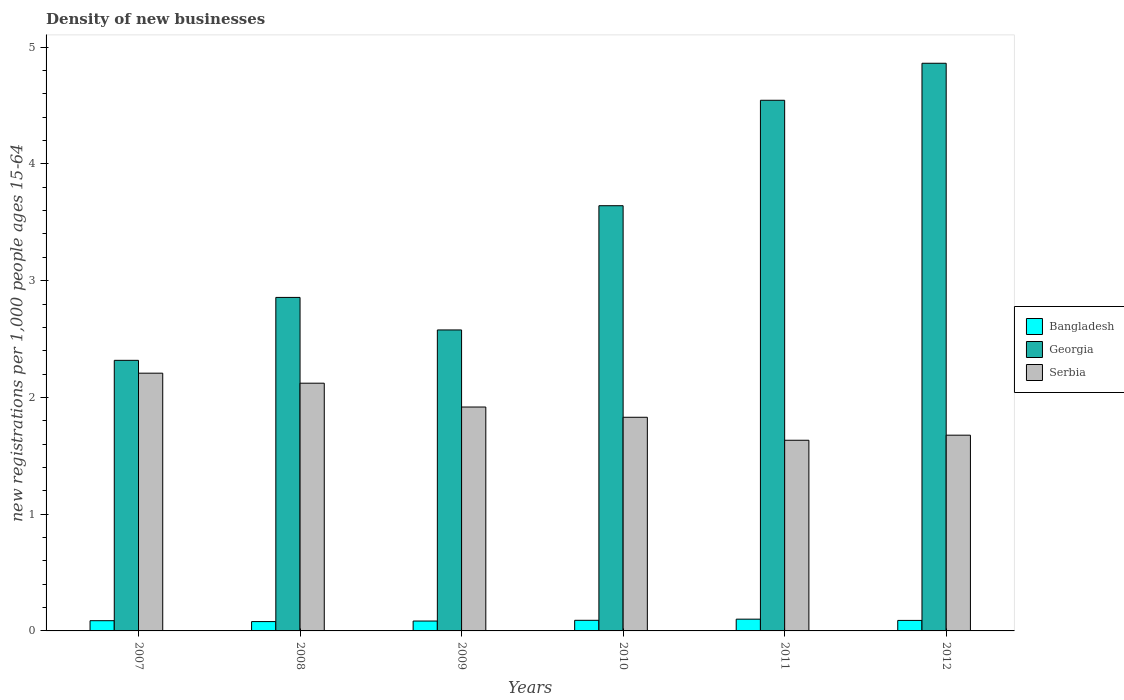How many different coloured bars are there?
Offer a terse response. 3. How many groups of bars are there?
Provide a short and direct response. 6. How many bars are there on the 3rd tick from the left?
Ensure brevity in your answer.  3. How many bars are there on the 5th tick from the right?
Provide a succinct answer. 3. In how many cases, is the number of bars for a given year not equal to the number of legend labels?
Your response must be concise. 0. What is the number of new registrations in Bangladesh in 2007?
Your answer should be compact. 0.09. Across all years, what is the maximum number of new registrations in Georgia?
Provide a short and direct response. 4.86. Across all years, what is the minimum number of new registrations in Georgia?
Offer a very short reply. 2.32. In which year was the number of new registrations in Serbia maximum?
Give a very brief answer. 2007. In which year was the number of new registrations in Bangladesh minimum?
Provide a short and direct response. 2008. What is the total number of new registrations in Serbia in the graph?
Offer a terse response. 11.39. What is the difference between the number of new registrations in Serbia in 2007 and that in 2009?
Ensure brevity in your answer.  0.29. What is the difference between the number of new registrations in Georgia in 2010 and the number of new registrations in Serbia in 2012?
Offer a terse response. 1.97. What is the average number of new registrations in Georgia per year?
Your answer should be very brief. 3.47. In the year 2007, what is the difference between the number of new registrations in Bangladesh and number of new registrations in Georgia?
Offer a very short reply. -2.23. What is the ratio of the number of new registrations in Bangladesh in 2009 to that in 2012?
Your answer should be compact. 0.94. Is the number of new registrations in Serbia in 2010 less than that in 2012?
Make the answer very short. No. What is the difference between the highest and the second highest number of new registrations in Serbia?
Make the answer very short. 0.09. What is the difference between the highest and the lowest number of new registrations in Georgia?
Give a very brief answer. 2.54. What does the 2nd bar from the left in 2008 represents?
Keep it short and to the point. Georgia. Is it the case that in every year, the sum of the number of new registrations in Bangladesh and number of new registrations in Georgia is greater than the number of new registrations in Serbia?
Offer a very short reply. Yes. Are the values on the major ticks of Y-axis written in scientific E-notation?
Keep it short and to the point. No. Does the graph contain grids?
Provide a succinct answer. No. How are the legend labels stacked?
Your answer should be compact. Vertical. What is the title of the graph?
Your answer should be compact. Density of new businesses. Does "High income" appear as one of the legend labels in the graph?
Give a very brief answer. No. What is the label or title of the X-axis?
Your answer should be compact. Years. What is the label or title of the Y-axis?
Your answer should be very brief. New registrations per 1,0 people ages 15-64. What is the new registrations per 1,000 people ages 15-64 of Bangladesh in 2007?
Offer a very short reply. 0.09. What is the new registrations per 1,000 people ages 15-64 in Georgia in 2007?
Provide a short and direct response. 2.32. What is the new registrations per 1,000 people ages 15-64 in Serbia in 2007?
Make the answer very short. 2.21. What is the new registrations per 1,000 people ages 15-64 of Bangladesh in 2008?
Provide a short and direct response. 0.08. What is the new registrations per 1,000 people ages 15-64 of Georgia in 2008?
Keep it short and to the point. 2.86. What is the new registrations per 1,000 people ages 15-64 in Serbia in 2008?
Offer a very short reply. 2.12. What is the new registrations per 1,000 people ages 15-64 of Bangladesh in 2009?
Offer a very short reply. 0.08. What is the new registrations per 1,000 people ages 15-64 of Georgia in 2009?
Your answer should be very brief. 2.58. What is the new registrations per 1,000 people ages 15-64 in Serbia in 2009?
Make the answer very short. 1.92. What is the new registrations per 1,000 people ages 15-64 in Bangladesh in 2010?
Your answer should be compact. 0.09. What is the new registrations per 1,000 people ages 15-64 in Georgia in 2010?
Give a very brief answer. 3.64. What is the new registrations per 1,000 people ages 15-64 in Serbia in 2010?
Keep it short and to the point. 1.83. What is the new registrations per 1,000 people ages 15-64 of Bangladesh in 2011?
Ensure brevity in your answer.  0.1. What is the new registrations per 1,000 people ages 15-64 in Georgia in 2011?
Your response must be concise. 4.55. What is the new registrations per 1,000 people ages 15-64 of Serbia in 2011?
Ensure brevity in your answer.  1.63. What is the new registrations per 1,000 people ages 15-64 of Bangladesh in 2012?
Your response must be concise. 0.09. What is the new registrations per 1,000 people ages 15-64 in Georgia in 2012?
Your answer should be very brief. 4.86. What is the new registrations per 1,000 people ages 15-64 in Serbia in 2012?
Offer a very short reply. 1.68. Across all years, what is the maximum new registrations per 1,000 people ages 15-64 in Bangladesh?
Offer a very short reply. 0.1. Across all years, what is the maximum new registrations per 1,000 people ages 15-64 of Georgia?
Make the answer very short. 4.86. Across all years, what is the maximum new registrations per 1,000 people ages 15-64 in Serbia?
Provide a short and direct response. 2.21. Across all years, what is the minimum new registrations per 1,000 people ages 15-64 of Bangladesh?
Make the answer very short. 0.08. Across all years, what is the minimum new registrations per 1,000 people ages 15-64 of Georgia?
Give a very brief answer. 2.32. Across all years, what is the minimum new registrations per 1,000 people ages 15-64 in Serbia?
Your answer should be very brief. 1.63. What is the total new registrations per 1,000 people ages 15-64 of Bangladesh in the graph?
Your answer should be very brief. 0.53. What is the total new registrations per 1,000 people ages 15-64 of Georgia in the graph?
Your answer should be very brief. 20.8. What is the total new registrations per 1,000 people ages 15-64 of Serbia in the graph?
Make the answer very short. 11.39. What is the difference between the new registrations per 1,000 people ages 15-64 of Bangladesh in 2007 and that in 2008?
Keep it short and to the point. 0.01. What is the difference between the new registrations per 1,000 people ages 15-64 in Georgia in 2007 and that in 2008?
Give a very brief answer. -0.54. What is the difference between the new registrations per 1,000 people ages 15-64 in Serbia in 2007 and that in 2008?
Your answer should be compact. 0.09. What is the difference between the new registrations per 1,000 people ages 15-64 in Bangladesh in 2007 and that in 2009?
Give a very brief answer. 0. What is the difference between the new registrations per 1,000 people ages 15-64 in Georgia in 2007 and that in 2009?
Provide a succinct answer. -0.26. What is the difference between the new registrations per 1,000 people ages 15-64 in Serbia in 2007 and that in 2009?
Your response must be concise. 0.29. What is the difference between the new registrations per 1,000 people ages 15-64 in Bangladesh in 2007 and that in 2010?
Your answer should be very brief. -0. What is the difference between the new registrations per 1,000 people ages 15-64 of Georgia in 2007 and that in 2010?
Your answer should be compact. -1.32. What is the difference between the new registrations per 1,000 people ages 15-64 of Serbia in 2007 and that in 2010?
Your answer should be compact. 0.38. What is the difference between the new registrations per 1,000 people ages 15-64 in Bangladesh in 2007 and that in 2011?
Your response must be concise. -0.01. What is the difference between the new registrations per 1,000 people ages 15-64 of Georgia in 2007 and that in 2011?
Your answer should be very brief. -2.23. What is the difference between the new registrations per 1,000 people ages 15-64 of Serbia in 2007 and that in 2011?
Offer a very short reply. 0.57. What is the difference between the new registrations per 1,000 people ages 15-64 in Bangladesh in 2007 and that in 2012?
Offer a terse response. -0. What is the difference between the new registrations per 1,000 people ages 15-64 of Georgia in 2007 and that in 2012?
Your response must be concise. -2.54. What is the difference between the new registrations per 1,000 people ages 15-64 in Serbia in 2007 and that in 2012?
Your response must be concise. 0.53. What is the difference between the new registrations per 1,000 people ages 15-64 of Bangladesh in 2008 and that in 2009?
Your answer should be compact. -0. What is the difference between the new registrations per 1,000 people ages 15-64 in Georgia in 2008 and that in 2009?
Your answer should be very brief. 0.28. What is the difference between the new registrations per 1,000 people ages 15-64 of Serbia in 2008 and that in 2009?
Make the answer very short. 0.2. What is the difference between the new registrations per 1,000 people ages 15-64 in Bangladesh in 2008 and that in 2010?
Offer a terse response. -0.01. What is the difference between the new registrations per 1,000 people ages 15-64 in Georgia in 2008 and that in 2010?
Your answer should be compact. -0.79. What is the difference between the new registrations per 1,000 people ages 15-64 in Serbia in 2008 and that in 2010?
Make the answer very short. 0.29. What is the difference between the new registrations per 1,000 people ages 15-64 of Bangladesh in 2008 and that in 2011?
Offer a terse response. -0.02. What is the difference between the new registrations per 1,000 people ages 15-64 in Georgia in 2008 and that in 2011?
Your answer should be compact. -1.69. What is the difference between the new registrations per 1,000 people ages 15-64 of Serbia in 2008 and that in 2011?
Make the answer very short. 0.49. What is the difference between the new registrations per 1,000 people ages 15-64 in Bangladesh in 2008 and that in 2012?
Make the answer very short. -0.01. What is the difference between the new registrations per 1,000 people ages 15-64 in Georgia in 2008 and that in 2012?
Your answer should be compact. -2.01. What is the difference between the new registrations per 1,000 people ages 15-64 in Serbia in 2008 and that in 2012?
Ensure brevity in your answer.  0.45. What is the difference between the new registrations per 1,000 people ages 15-64 of Bangladesh in 2009 and that in 2010?
Ensure brevity in your answer.  -0.01. What is the difference between the new registrations per 1,000 people ages 15-64 of Georgia in 2009 and that in 2010?
Offer a very short reply. -1.06. What is the difference between the new registrations per 1,000 people ages 15-64 of Serbia in 2009 and that in 2010?
Your response must be concise. 0.09. What is the difference between the new registrations per 1,000 people ages 15-64 in Bangladesh in 2009 and that in 2011?
Your answer should be compact. -0.02. What is the difference between the new registrations per 1,000 people ages 15-64 of Georgia in 2009 and that in 2011?
Give a very brief answer. -1.97. What is the difference between the new registrations per 1,000 people ages 15-64 of Serbia in 2009 and that in 2011?
Offer a very short reply. 0.28. What is the difference between the new registrations per 1,000 people ages 15-64 in Bangladesh in 2009 and that in 2012?
Keep it short and to the point. -0.01. What is the difference between the new registrations per 1,000 people ages 15-64 of Georgia in 2009 and that in 2012?
Your response must be concise. -2.28. What is the difference between the new registrations per 1,000 people ages 15-64 in Serbia in 2009 and that in 2012?
Keep it short and to the point. 0.24. What is the difference between the new registrations per 1,000 people ages 15-64 in Bangladesh in 2010 and that in 2011?
Your response must be concise. -0.01. What is the difference between the new registrations per 1,000 people ages 15-64 in Georgia in 2010 and that in 2011?
Your answer should be very brief. -0.9. What is the difference between the new registrations per 1,000 people ages 15-64 of Serbia in 2010 and that in 2011?
Your answer should be compact. 0.2. What is the difference between the new registrations per 1,000 people ages 15-64 in Bangladesh in 2010 and that in 2012?
Offer a terse response. 0. What is the difference between the new registrations per 1,000 people ages 15-64 in Georgia in 2010 and that in 2012?
Your answer should be compact. -1.22. What is the difference between the new registrations per 1,000 people ages 15-64 in Serbia in 2010 and that in 2012?
Ensure brevity in your answer.  0.15. What is the difference between the new registrations per 1,000 people ages 15-64 in Bangladesh in 2011 and that in 2012?
Your answer should be compact. 0.01. What is the difference between the new registrations per 1,000 people ages 15-64 in Georgia in 2011 and that in 2012?
Provide a short and direct response. -0.32. What is the difference between the new registrations per 1,000 people ages 15-64 of Serbia in 2011 and that in 2012?
Provide a short and direct response. -0.04. What is the difference between the new registrations per 1,000 people ages 15-64 of Bangladesh in 2007 and the new registrations per 1,000 people ages 15-64 of Georgia in 2008?
Give a very brief answer. -2.77. What is the difference between the new registrations per 1,000 people ages 15-64 of Bangladesh in 2007 and the new registrations per 1,000 people ages 15-64 of Serbia in 2008?
Make the answer very short. -2.03. What is the difference between the new registrations per 1,000 people ages 15-64 of Georgia in 2007 and the new registrations per 1,000 people ages 15-64 of Serbia in 2008?
Ensure brevity in your answer.  0.2. What is the difference between the new registrations per 1,000 people ages 15-64 in Bangladesh in 2007 and the new registrations per 1,000 people ages 15-64 in Georgia in 2009?
Offer a very short reply. -2.49. What is the difference between the new registrations per 1,000 people ages 15-64 of Bangladesh in 2007 and the new registrations per 1,000 people ages 15-64 of Serbia in 2009?
Provide a short and direct response. -1.83. What is the difference between the new registrations per 1,000 people ages 15-64 of Bangladesh in 2007 and the new registrations per 1,000 people ages 15-64 of Georgia in 2010?
Offer a very short reply. -3.55. What is the difference between the new registrations per 1,000 people ages 15-64 in Bangladesh in 2007 and the new registrations per 1,000 people ages 15-64 in Serbia in 2010?
Your response must be concise. -1.74. What is the difference between the new registrations per 1,000 people ages 15-64 in Georgia in 2007 and the new registrations per 1,000 people ages 15-64 in Serbia in 2010?
Offer a terse response. 0.49. What is the difference between the new registrations per 1,000 people ages 15-64 in Bangladesh in 2007 and the new registrations per 1,000 people ages 15-64 in Georgia in 2011?
Give a very brief answer. -4.46. What is the difference between the new registrations per 1,000 people ages 15-64 in Bangladesh in 2007 and the new registrations per 1,000 people ages 15-64 in Serbia in 2011?
Make the answer very short. -1.55. What is the difference between the new registrations per 1,000 people ages 15-64 of Georgia in 2007 and the new registrations per 1,000 people ages 15-64 of Serbia in 2011?
Offer a terse response. 0.68. What is the difference between the new registrations per 1,000 people ages 15-64 in Bangladesh in 2007 and the new registrations per 1,000 people ages 15-64 in Georgia in 2012?
Ensure brevity in your answer.  -4.77. What is the difference between the new registrations per 1,000 people ages 15-64 of Bangladesh in 2007 and the new registrations per 1,000 people ages 15-64 of Serbia in 2012?
Ensure brevity in your answer.  -1.59. What is the difference between the new registrations per 1,000 people ages 15-64 of Georgia in 2007 and the new registrations per 1,000 people ages 15-64 of Serbia in 2012?
Offer a very short reply. 0.64. What is the difference between the new registrations per 1,000 people ages 15-64 in Bangladesh in 2008 and the new registrations per 1,000 people ages 15-64 in Georgia in 2009?
Offer a very short reply. -2.5. What is the difference between the new registrations per 1,000 people ages 15-64 in Bangladesh in 2008 and the new registrations per 1,000 people ages 15-64 in Serbia in 2009?
Your response must be concise. -1.84. What is the difference between the new registrations per 1,000 people ages 15-64 in Georgia in 2008 and the new registrations per 1,000 people ages 15-64 in Serbia in 2009?
Give a very brief answer. 0.94. What is the difference between the new registrations per 1,000 people ages 15-64 in Bangladesh in 2008 and the new registrations per 1,000 people ages 15-64 in Georgia in 2010?
Make the answer very short. -3.56. What is the difference between the new registrations per 1,000 people ages 15-64 in Bangladesh in 2008 and the new registrations per 1,000 people ages 15-64 in Serbia in 2010?
Ensure brevity in your answer.  -1.75. What is the difference between the new registrations per 1,000 people ages 15-64 in Georgia in 2008 and the new registrations per 1,000 people ages 15-64 in Serbia in 2010?
Give a very brief answer. 1.03. What is the difference between the new registrations per 1,000 people ages 15-64 in Bangladesh in 2008 and the new registrations per 1,000 people ages 15-64 in Georgia in 2011?
Your answer should be very brief. -4.47. What is the difference between the new registrations per 1,000 people ages 15-64 of Bangladesh in 2008 and the new registrations per 1,000 people ages 15-64 of Serbia in 2011?
Your answer should be very brief. -1.55. What is the difference between the new registrations per 1,000 people ages 15-64 in Georgia in 2008 and the new registrations per 1,000 people ages 15-64 in Serbia in 2011?
Provide a succinct answer. 1.22. What is the difference between the new registrations per 1,000 people ages 15-64 of Bangladesh in 2008 and the new registrations per 1,000 people ages 15-64 of Georgia in 2012?
Your answer should be compact. -4.78. What is the difference between the new registrations per 1,000 people ages 15-64 in Bangladesh in 2008 and the new registrations per 1,000 people ages 15-64 in Serbia in 2012?
Ensure brevity in your answer.  -1.6. What is the difference between the new registrations per 1,000 people ages 15-64 of Georgia in 2008 and the new registrations per 1,000 people ages 15-64 of Serbia in 2012?
Provide a short and direct response. 1.18. What is the difference between the new registrations per 1,000 people ages 15-64 in Bangladesh in 2009 and the new registrations per 1,000 people ages 15-64 in Georgia in 2010?
Your answer should be compact. -3.56. What is the difference between the new registrations per 1,000 people ages 15-64 in Bangladesh in 2009 and the new registrations per 1,000 people ages 15-64 in Serbia in 2010?
Make the answer very short. -1.75. What is the difference between the new registrations per 1,000 people ages 15-64 in Georgia in 2009 and the new registrations per 1,000 people ages 15-64 in Serbia in 2010?
Give a very brief answer. 0.75. What is the difference between the new registrations per 1,000 people ages 15-64 of Bangladesh in 2009 and the new registrations per 1,000 people ages 15-64 of Georgia in 2011?
Keep it short and to the point. -4.46. What is the difference between the new registrations per 1,000 people ages 15-64 in Bangladesh in 2009 and the new registrations per 1,000 people ages 15-64 in Serbia in 2011?
Provide a short and direct response. -1.55. What is the difference between the new registrations per 1,000 people ages 15-64 of Georgia in 2009 and the new registrations per 1,000 people ages 15-64 of Serbia in 2011?
Give a very brief answer. 0.94. What is the difference between the new registrations per 1,000 people ages 15-64 of Bangladesh in 2009 and the new registrations per 1,000 people ages 15-64 of Georgia in 2012?
Keep it short and to the point. -4.78. What is the difference between the new registrations per 1,000 people ages 15-64 of Bangladesh in 2009 and the new registrations per 1,000 people ages 15-64 of Serbia in 2012?
Your answer should be very brief. -1.59. What is the difference between the new registrations per 1,000 people ages 15-64 of Georgia in 2009 and the new registrations per 1,000 people ages 15-64 of Serbia in 2012?
Your answer should be very brief. 0.9. What is the difference between the new registrations per 1,000 people ages 15-64 of Bangladesh in 2010 and the new registrations per 1,000 people ages 15-64 of Georgia in 2011?
Your answer should be compact. -4.45. What is the difference between the new registrations per 1,000 people ages 15-64 in Bangladesh in 2010 and the new registrations per 1,000 people ages 15-64 in Serbia in 2011?
Your answer should be compact. -1.54. What is the difference between the new registrations per 1,000 people ages 15-64 of Georgia in 2010 and the new registrations per 1,000 people ages 15-64 of Serbia in 2011?
Offer a very short reply. 2.01. What is the difference between the new registrations per 1,000 people ages 15-64 in Bangladesh in 2010 and the new registrations per 1,000 people ages 15-64 in Georgia in 2012?
Keep it short and to the point. -4.77. What is the difference between the new registrations per 1,000 people ages 15-64 in Bangladesh in 2010 and the new registrations per 1,000 people ages 15-64 in Serbia in 2012?
Offer a terse response. -1.59. What is the difference between the new registrations per 1,000 people ages 15-64 in Georgia in 2010 and the new registrations per 1,000 people ages 15-64 in Serbia in 2012?
Make the answer very short. 1.97. What is the difference between the new registrations per 1,000 people ages 15-64 in Bangladesh in 2011 and the new registrations per 1,000 people ages 15-64 in Georgia in 2012?
Provide a short and direct response. -4.76. What is the difference between the new registrations per 1,000 people ages 15-64 in Bangladesh in 2011 and the new registrations per 1,000 people ages 15-64 in Serbia in 2012?
Keep it short and to the point. -1.58. What is the difference between the new registrations per 1,000 people ages 15-64 of Georgia in 2011 and the new registrations per 1,000 people ages 15-64 of Serbia in 2012?
Give a very brief answer. 2.87. What is the average new registrations per 1,000 people ages 15-64 of Bangladesh per year?
Make the answer very short. 0.09. What is the average new registrations per 1,000 people ages 15-64 in Georgia per year?
Your response must be concise. 3.47. What is the average new registrations per 1,000 people ages 15-64 of Serbia per year?
Provide a short and direct response. 1.9. In the year 2007, what is the difference between the new registrations per 1,000 people ages 15-64 of Bangladesh and new registrations per 1,000 people ages 15-64 of Georgia?
Offer a very short reply. -2.23. In the year 2007, what is the difference between the new registrations per 1,000 people ages 15-64 in Bangladesh and new registrations per 1,000 people ages 15-64 in Serbia?
Provide a short and direct response. -2.12. In the year 2007, what is the difference between the new registrations per 1,000 people ages 15-64 of Georgia and new registrations per 1,000 people ages 15-64 of Serbia?
Offer a very short reply. 0.11. In the year 2008, what is the difference between the new registrations per 1,000 people ages 15-64 in Bangladesh and new registrations per 1,000 people ages 15-64 in Georgia?
Provide a short and direct response. -2.78. In the year 2008, what is the difference between the new registrations per 1,000 people ages 15-64 of Bangladesh and new registrations per 1,000 people ages 15-64 of Serbia?
Keep it short and to the point. -2.04. In the year 2008, what is the difference between the new registrations per 1,000 people ages 15-64 of Georgia and new registrations per 1,000 people ages 15-64 of Serbia?
Keep it short and to the point. 0.73. In the year 2009, what is the difference between the new registrations per 1,000 people ages 15-64 in Bangladesh and new registrations per 1,000 people ages 15-64 in Georgia?
Make the answer very short. -2.49. In the year 2009, what is the difference between the new registrations per 1,000 people ages 15-64 of Bangladesh and new registrations per 1,000 people ages 15-64 of Serbia?
Keep it short and to the point. -1.83. In the year 2009, what is the difference between the new registrations per 1,000 people ages 15-64 in Georgia and new registrations per 1,000 people ages 15-64 in Serbia?
Ensure brevity in your answer.  0.66. In the year 2010, what is the difference between the new registrations per 1,000 people ages 15-64 in Bangladesh and new registrations per 1,000 people ages 15-64 in Georgia?
Offer a terse response. -3.55. In the year 2010, what is the difference between the new registrations per 1,000 people ages 15-64 of Bangladesh and new registrations per 1,000 people ages 15-64 of Serbia?
Your answer should be very brief. -1.74. In the year 2010, what is the difference between the new registrations per 1,000 people ages 15-64 in Georgia and new registrations per 1,000 people ages 15-64 in Serbia?
Your answer should be very brief. 1.81. In the year 2011, what is the difference between the new registrations per 1,000 people ages 15-64 in Bangladesh and new registrations per 1,000 people ages 15-64 in Georgia?
Offer a very short reply. -4.44. In the year 2011, what is the difference between the new registrations per 1,000 people ages 15-64 in Bangladesh and new registrations per 1,000 people ages 15-64 in Serbia?
Keep it short and to the point. -1.53. In the year 2011, what is the difference between the new registrations per 1,000 people ages 15-64 in Georgia and new registrations per 1,000 people ages 15-64 in Serbia?
Provide a succinct answer. 2.91. In the year 2012, what is the difference between the new registrations per 1,000 people ages 15-64 in Bangladesh and new registrations per 1,000 people ages 15-64 in Georgia?
Your answer should be very brief. -4.77. In the year 2012, what is the difference between the new registrations per 1,000 people ages 15-64 of Bangladesh and new registrations per 1,000 people ages 15-64 of Serbia?
Your response must be concise. -1.59. In the year 2012, what is the difference between the new registrations per 1,000 people ages 15-64 in Georgia and new registrations per 1,000 people ages 15-64 in Serbia?
Offer a terse response. 3.19. What is the ratio of the new registrations per 1,000 people ages 15-64 in Bangladesh in 2007 to that in 2008?
Provide a short and direct response. 1.1. What is the ratio of the new registrations per 1,000 people ages 15-64 of Georgia in 2007 to that in 2008?
Make the answer very short. 0.81. What is the ratio of the new registrations per 1,000 people ages 15-64 in Serbia in 2007 to that in 2008?
Your answer should be compact. 1.04. What is the ratio of the new registrations per 1,000 people ages 15-64 of Bangladesh in 2007 to that in 2009?
Your answer should be very brief. 1.03. What is the ratio of the new registrations per 1,000 people ages 15-64 in Georgia in 2007 to that in 2009?
Provide a succinct answer. 0.9. What is the ratio of the new registrations per 1,000 people ages 15-64 in Serbia in 2007 to that in 2009?
Provide a succinct answer. 1.15. What is the ratio of the new registrations per 1,000 people ages 15-64 of Bangladesh in 2007 to that in 2010?
Offer a terse response. 0.96. What is the ratio of the new registrations per 1,000 people ages 15-64 of Georgia in 2007 to that in 2010?
Provide a short and direct response. 0.64. What is the ratio of the new registrations per 1,000 people ages 15-64 of Serbia in 2007 to that in 2010?
Provide a short and direct response. 1.21. What is the ratio of the new registrations per 1,000 people ages 15-64 of Bangladesh in 2007 to that in 2011?
Make the answer very short. 0.87. What is the ratio of the new registrations per 1,000 people ages 15-64 in Georgia in 2007 to that in 2011?
Your answer should be compact. 0.51. What is the ratio of the new registrations per 1,000 people ages 15-64 in Serbia in 2007 to that in 2011?
Provide a short and direct response. 1.35. What is the ratio of the new registrations per 1,000 people ages 15-64 in Bangladesh in 2007 to that in 2012?
Make the answer very short. 0.97. What is the ratio of the new registrations per 1,000 people ages 15-64 of Georgia in 2007 to that in 2012?
Keep it short and to the point. 0.48. What is the ratio of the new registrations per 1,000 people ages 15-64 of Serbia in 2007 to that in 2012?
Provide a short and direct response. 1.32. What is the ratio of the new registrations per 1,000 people ages 15-64 in Bangladesh in 2008 to that in 2009?
Your response must be concise. 0.94. What is the ratio of the new registrations per 1,000 people ages 15-64 of Georgia in 2008 to that in 2009?
Your answer should be very brief. 1.11. What is the ratio of the new registrations per 1,000 people ages 15-64 in Serbia in 2008 to that in 2009?
Your answer should be compact. 1.11. What is the ratio of the new registrations per 1,000 people ages 15-64 of Bangladesh in 2008 to that in 2010?
Provide a succinct answer. 0.88. What is the ratio of the new registrations per 1,000 people ages 15-64 in Georgia in 2008 to that in 2010?
Make the answer very short. 0.78. What is the ratio of the new registrations per 1,000 people ages 15-64 in Serbia in 2008 to that in 2010?
Your response must be concise. 1.16. What is the ratio of the new registrations per 1,000 people ages 15-64 in Bangladesh in 2008 to that in 2011?
Make the answer very short. 0.79. What is the ratio of the new registrations per 1,000 people ages 15-64 of Georgia in 2008 to that in 2011?
Ensure brevity in your answer.  0.63. What is the ratio of the new registrations per 1,000 people ages 15-64 in Serbia in 2008 to that in 2011?
Give a very brief answer. 1.3. What is the ratio of the new registrations per 1,000 people ages 15-64 of Bangladesh in 2008 to that in 2012?
Keep it short and to the point. 0.89. What is the ratio of the new registrations per 1,000 people ages 15-64 in Georgia in 2008 to that in 2012?
Your answer should be compact. 0.59. What is the ratio of the new registrations per 1,000 people ages 15-64 of Serbia in 2008 to that in 2012?
Make the answer very short. 1.27. What is the ratio of the new registrations per 1,000 people ages 15-64 in Bangladesh in 2009 to that in 2010?
Your response must be concise. 0.93. What is the ratio of the new registrations per 1,000 people ages 15-64 of Georgia in 2009 to that in 2010?
Your response must be concise. 0.71. What is the ratio of the new registrations per 1,000 people ages 15-64 of Serbia in 2009 to that in 2010?
Your answer should be compact. 1.05. What is the ratio of the new registrations per 1,000 people ages 15-64 of Bangladesh in 2009 to that in 2011?
Offer a very short reply. 0.84. What is the ratio of the new registrations per 1,000 people ages 15-64 in Georgia in 2009 to that in 2011?
Keep it short and to the point. 0.57. What is the ratio of the new registrations per 1,000 people ages 15-64 in Serbia in 2009 to that in 2011?
Your response must be concise. 1.17. What is the ratio of the new registrations per 1,000 people ages 15-64 in Bangladesh in 2009 to that in 2012?
Your answer should be very brief. 0.94. What is the ratio of the new registrations per 1,000 people ages 15-64 in Georgia in 2009 to that in 2012?
Your response must be concise. 0.53. What is the ratio of the new registrations per 1,000 people ages 15-64 in Serbia in 2009 to that in 2012?
Provide a short and direct response. 1.14. What is the ratio of the new registrations per 1,000 people ages 15-64 of Bangladesh in 2010 to that in 2011?
Provide a short and direct response. 0.9. What is the ratio of the new registrations per 1,000 people ages 15-64 of Georgia in 2010 to that in 2011?
Your answer should be compact. 0.8. What is the ratio of the new registrations per 1,000 people ages 15-64 in Serbia in 2010 to that in 2011?
Your answer should be very brief. 1.12. What is the ratio of the new registrations per 1,000 people ages 15-64 in Bangladesh in 2010 to that in 2012?
Your answer should be compact. 1.01. What is the ratio of the new registrations per 1,000 people ages 15-64 of Georgia in 2010 to that in 2012?
Provide a succinct answer. 0.75. What is the ratio of the new registrations per 1,000 people ages 15-64 in Serbia in 2010 to that in 2012?
Your response must be concise. 1.09. What is the ratio of the new registrations per 1,000 people ages 15-64 of Bangladesh in 2011 to that in 2012?
Offer a terse response. 1.12. What is the ratio of the new registrations per 1,000 people ages 15-64 in Georgia in 2011 to that in 2012?
Your response must be concise. 0.93. What is the ratio of the new registrations per 1,000 people ages 15-64 of Serbia in 2011 to that in 2012?
Your answer should be very brief. 0.97. What is the difference between the highest and the second highest new registrations per 1,000 people ages 15-64 in Bangladesh?
Your answer should be very brief. 0.01. What is the difference between the highest and the second highest new registrations per 1,000 people ages 15-64 of Georgia?
Give a very brief answer. 0.32. What is the difference between the highest and the second highest new registrations per 1,000 people ages 15-64 of Serbia?
Your answer should be compact. 0.09. What is the difference between the highest and the lowest new registrations per 1,000 people ages 15-64 of Bangladesh?
Keep it short and to the point. 0.02. What is the difference between the highest and the lowest new registrations per 1,000 people ages 15-64 of Georgia?
Your response must be concise. 2.54. What is the difference between the highest and the lowest new registrations per 1,000 people ages 15-64 in Serbia?
Ensure brevity in your answer.  0.57. 